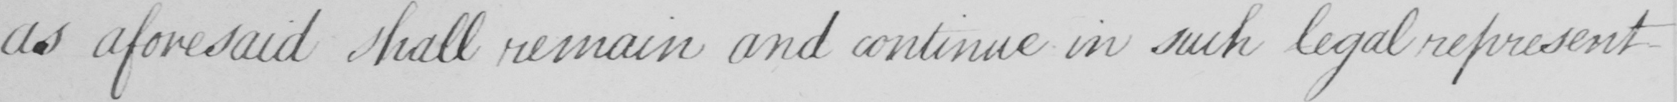Please transcribe the handwritten text in this image. as aforesaid shall remain and continue in such legal representatives 